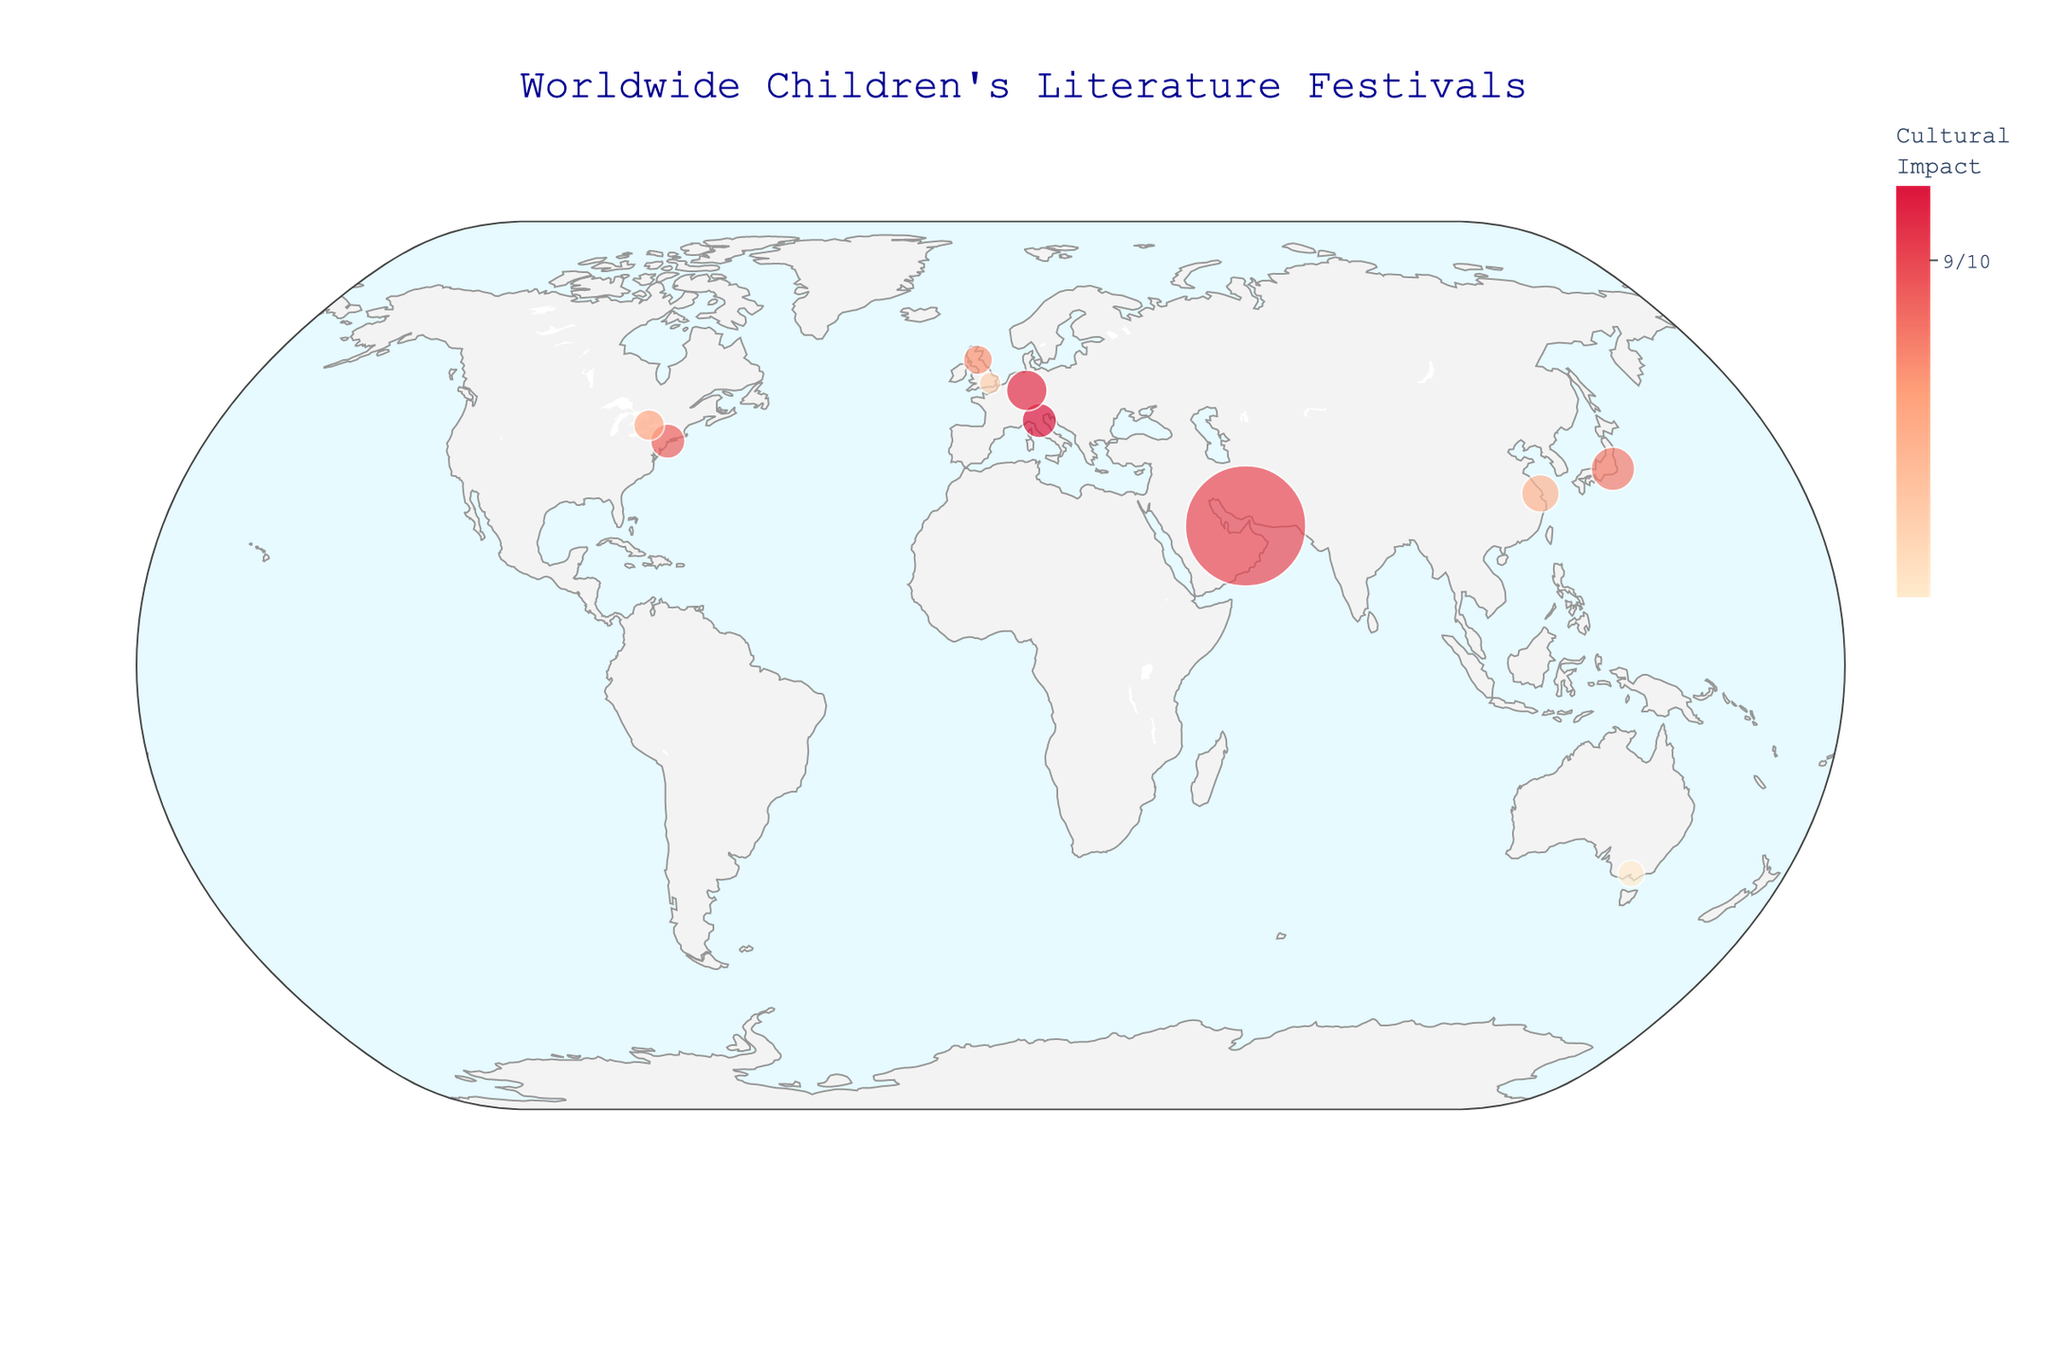What event has the highest attendance? By examining the figure, we look for the largest sized circle representing the event. The Sharjah Children's Reading Festival has the highest attendance, with the largest marker.
Answer: Sharjah Children's Reading Festival What is the location of the Tokyo International Children's Book Fair in terms of latitude and longitude? We find the Tokyo International Children's Book Fair on the plot and check its displayed coordinates using the hover tool.
Answer: Latitude: 35.6762, Longitude: 139.6503 Which event has the highest cultural impact score, and where is it located? We look for the event with the darkest-colored marker (indicative of high cultural impact). The Bologna Children's Book Fair has the highest impact score of 9.2 and is located in Bologna.
Answer: Bologna Children's Book Fair, Bologna How does the attendance of the Edinburgh International Book Festival compare to that of the Melbourne Children's Book Festival? Comparing the sizes of the markers, the Edinburgh International Book Festival's marker is larger than that of the Melbourne Children's Book Festival, indicating higher attendance.
Answer: Edinburgh International Book Festival has higher attendance What is the total attendance for all listed events? Summing the attendance figures from all events: 25000 + 18000 + 30000 + 305000 + 25000 + 40000 + 10000 + 15000 + 35000 + 20000 = 493,000
Answer: 493,000 What is the average cultural impact score of all the events? Adding the cultural impact scores: 9.2 + 8.7 + 8.5 + 9.0 + 8.9 + 8.8 + 8.3 + 8.1 + 9.1 + 8.6 = 87.2, dividing by the number of events: 87.2/10 = 8.72
Answer: 8.72 Which event has the smallest attendance, and what is its cultural impact score? We look for the event with the smallest marker. The Barnes Children's Literature Festival has the smallest attendance and a cultural impact score of 8.3.
Answer: Barnes Children's Literature Festival, 8.3 What is the combined attendance for the events in Europe? Summing the attendance for Bologna, Edinburgh, London, and Frankfurt: 25000 + 18000 + 10000 + 35000 = 88,000
Answer: 88,000 Which event is the most culturally impactful in North America? Checking the cultural impact scores for events in North America (New York and Toronto), the New York International Children's Film Festival has a higher impact score of 8.9 compared to Toronto's 8.6.
Answer: New York International Children's Film Festival 